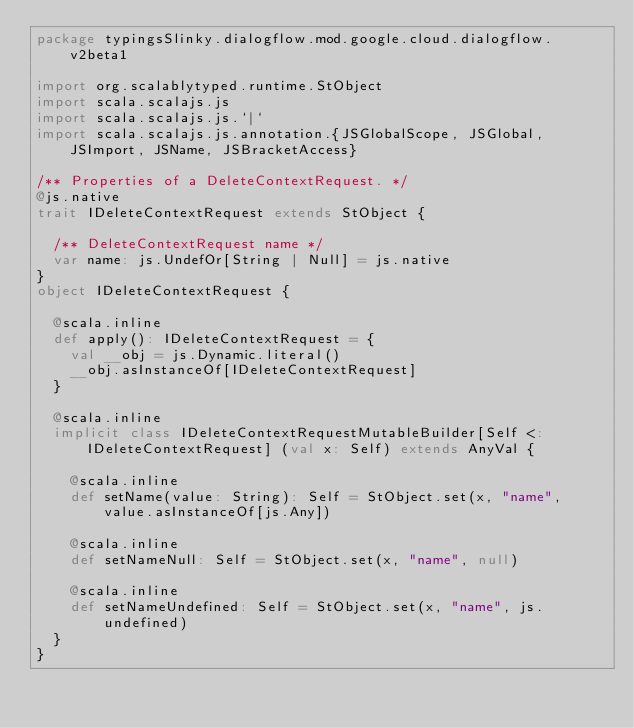<code> <loc_0><loc_0><loc_500><loc_500><_Scala_>package typingsSlinky.dialogflow.mod.google.cloud.dialogflow.v2beta1

import org.scalablytyped.runtime.StObject
import scala.scalajs.js
import scala.scalajs.js.`|`
import scala.scalajs.js.annotation.{JSGlobalScope, JSGlobal, JSImport, JSName, JSBracketAccess}

/** Properties of a DeleteContextRequest. */
@js.native
trait IDeleteContextRequest extends StObject {
  
  /** DeleteContextRequest name */
  var name: js.UndefOr[String | Null] = js.native
}
object IDeleteContextRequest {
  
  @scala.inline
  def apply(): IDeleteContextRequest = {
    val __obj = js.Dynamic.literal()
    __obj.asInstanceOf[IDeleteContextRequest]
  }
  
  @scala.inline
  implicit class IDeleteContextRequestMutableBuilder[Self <: IDeleteContextRequest] (val x: Self) extends AnyVal {
    
    @scala.inline
    def setName(value: String): Self = StObject.set(x, "name", value.asInstanceOf[js.Any])
    
    @scala.inline
    def setNameNull: Self = StObject.set(x, "name", null)
    
    @scala.inline
    def setNameUndefined: Self = StObject.set(x, "name", js.undefined)
  }
}
</code> 